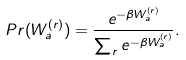Convert formula to latex. <formula><loc_0><loc_0><loc_500><loc_500>P r ( W _ { a } ^ { ( r ) } ) = \frac { e ^ { - \beta W _ { a } ^ { ( r ) } } } { \sum _ { r } e ^ { - \beta W _ { a } ^ { ( r ) } } } .</formula> 